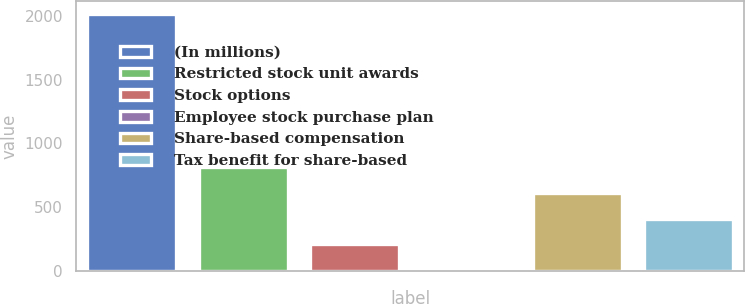<chart> <loc_0><loc_0><loc_500><loc_500><bar_chart><fcel>(In millions)<fcel>Restricted stock unit awards<fcel>Stock options<fcel>Employee stock purchase plan<fcel>Share-based compensation<fcel>Tax benefit for share-based<nl><fcel>2013<fcel>811.8<fcel>211.2<fcel>11<fcel>611.6<fcel>411.4<nl></chart> 